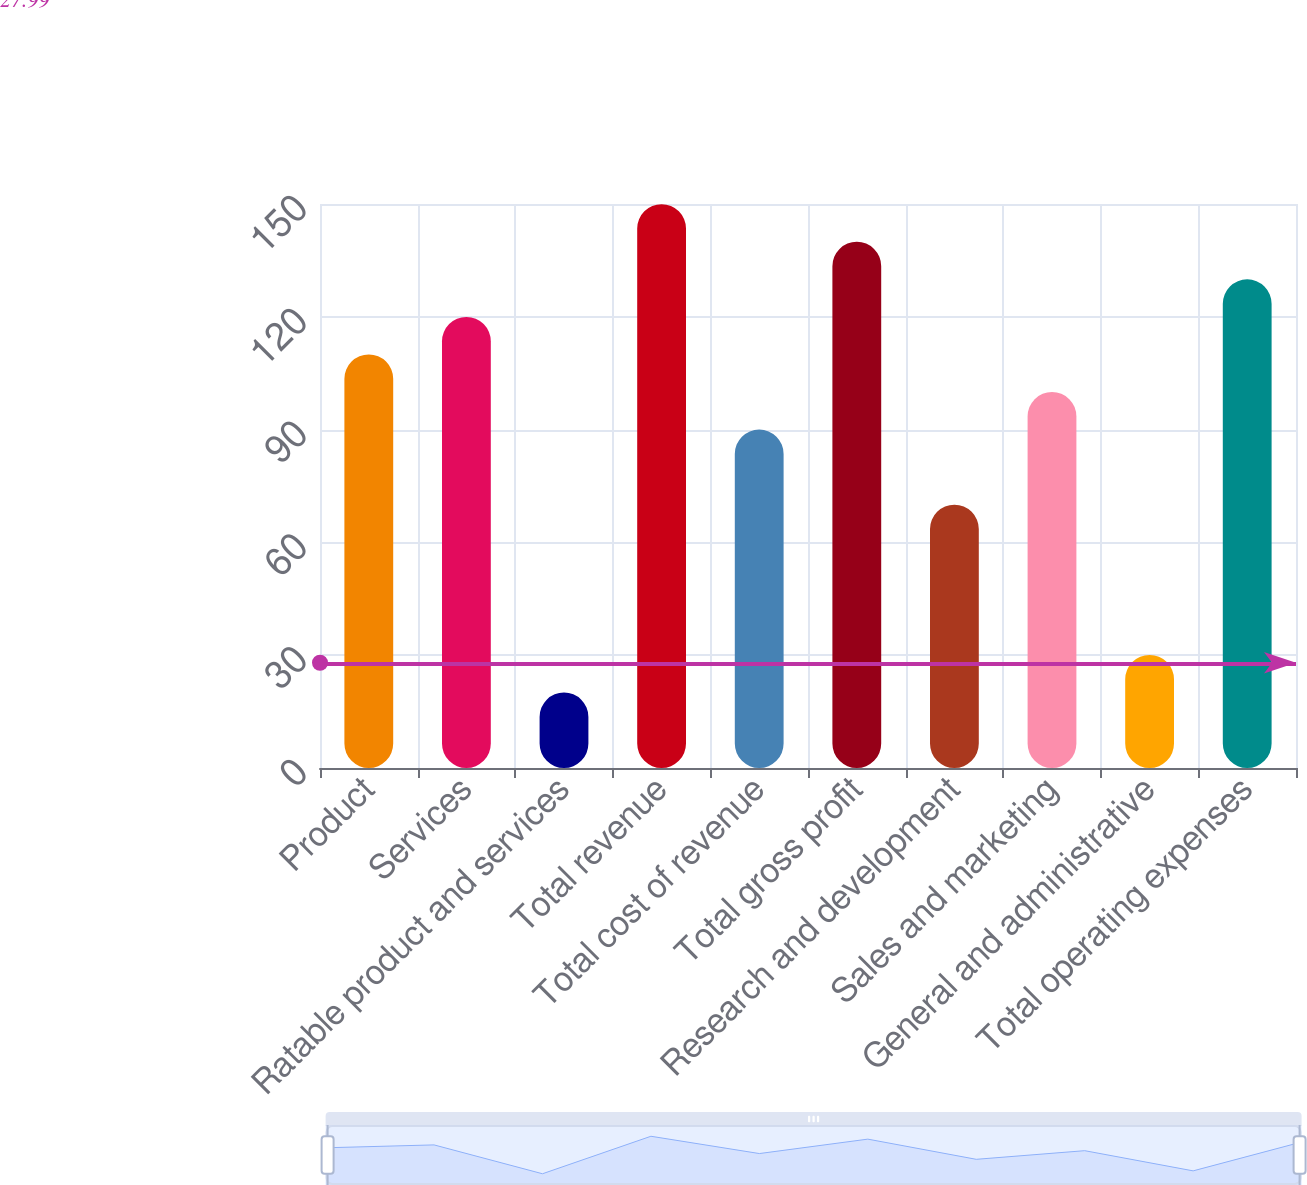Convert chart to OTSL. <chart><loc_0><loc_0><loc_500><loc_500><bar_chart><fcel>Product<fcel>Services<fcel>Ratable product and services<fcel>Total revenue<fcel>Total cost of revenue<fcel>Total gross profit<fcel>Research and development<fcel>Sales and marketing<fcel>General and administrative<fcel>Total operating expenses<nl><fcel>109.99<fcel>119.98<fcel>20.08<fcel>149.95<fcel>90.01<fcel>139.96<fcel>70.03<fcel>100<fcel>30.07<fcel>129.97<nl></chart> 